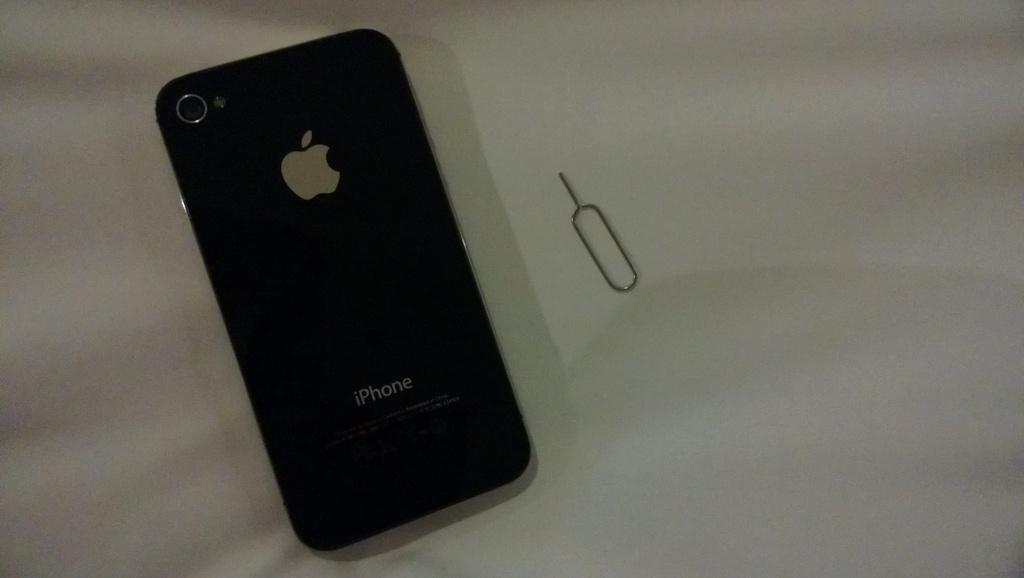<image>
Give a short and clear explanation of the subsequent image. an apple iphone is laying on a sheet beside a wire 